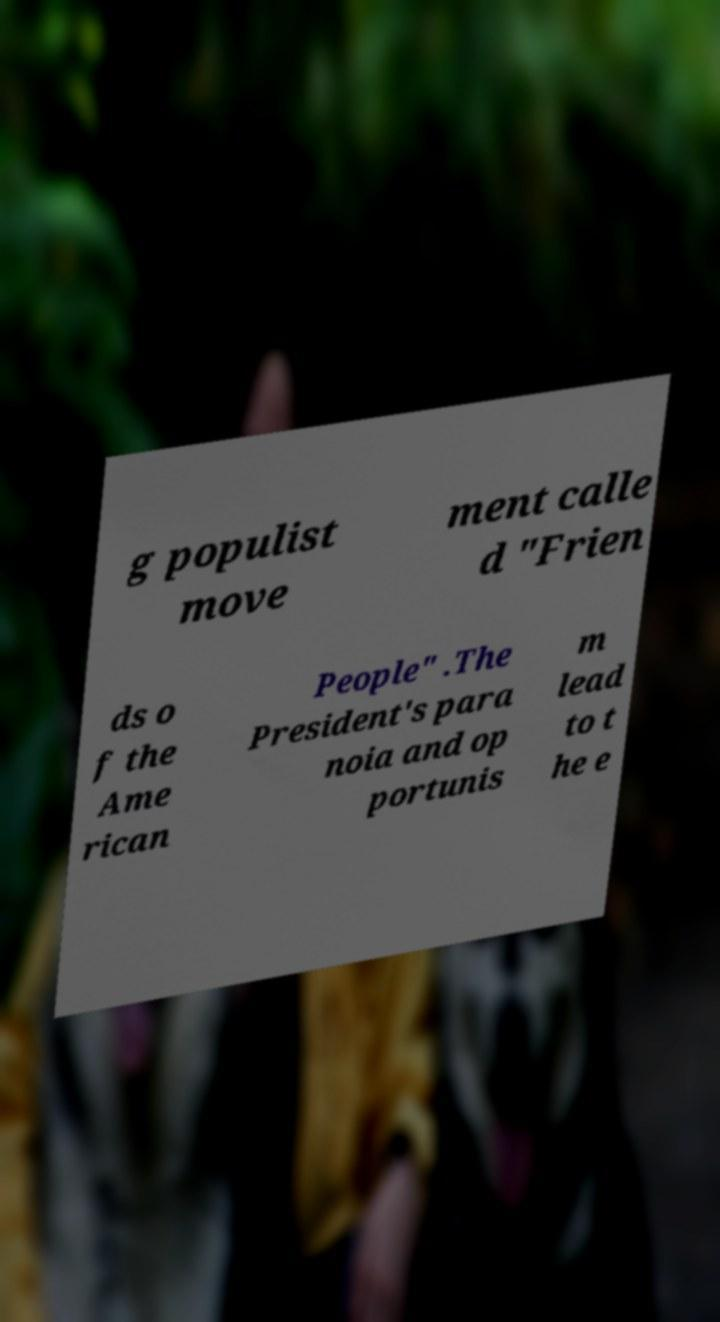What messages or text are displayed in this image? I need them in a readable, typed format. g populist move ment calle d "Frien ds o f the Ame rican People" .The President's para noia and op portunis m lead to t he e 